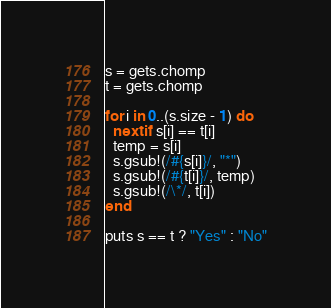<code> <loc_0><loc_0><loc_500><loc_500><_Ruby_>s = gets.chomp
t = gets.chomp

for i in 0..(s.size - 1) do
  next if s[i] == t[i]
  temp = s[i]
  s.gsub!(/#{s[i]}/, "*")
  s.gsub!(/#{t[i]}/, temp)
  s.gsub!(/\*/, t[i])
end

puts s == t ? "Yes" : "No"</code> 